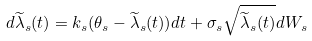<formula> <loc_0><loc_0><loc_500><loc_500>d \widetilde { \lambda } _ { s } ( t ) = k _ { s } ( \theta _ { s } - \widetilde { \lambda } _ { s } ( t ) ) d t + \sigma _ { s } \sqrt { \widetilde { \lambda } _ { s } ( t ) } d W _ { s }</formula> 